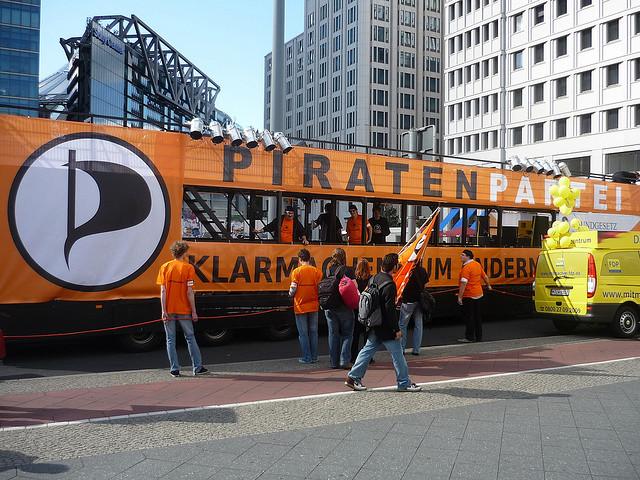How many people are on the street?
Answer briefly. 7. Where are yellow balloons?
Quick response, please. On truck. What color is the van?
Write a very short answer. Yellow. 